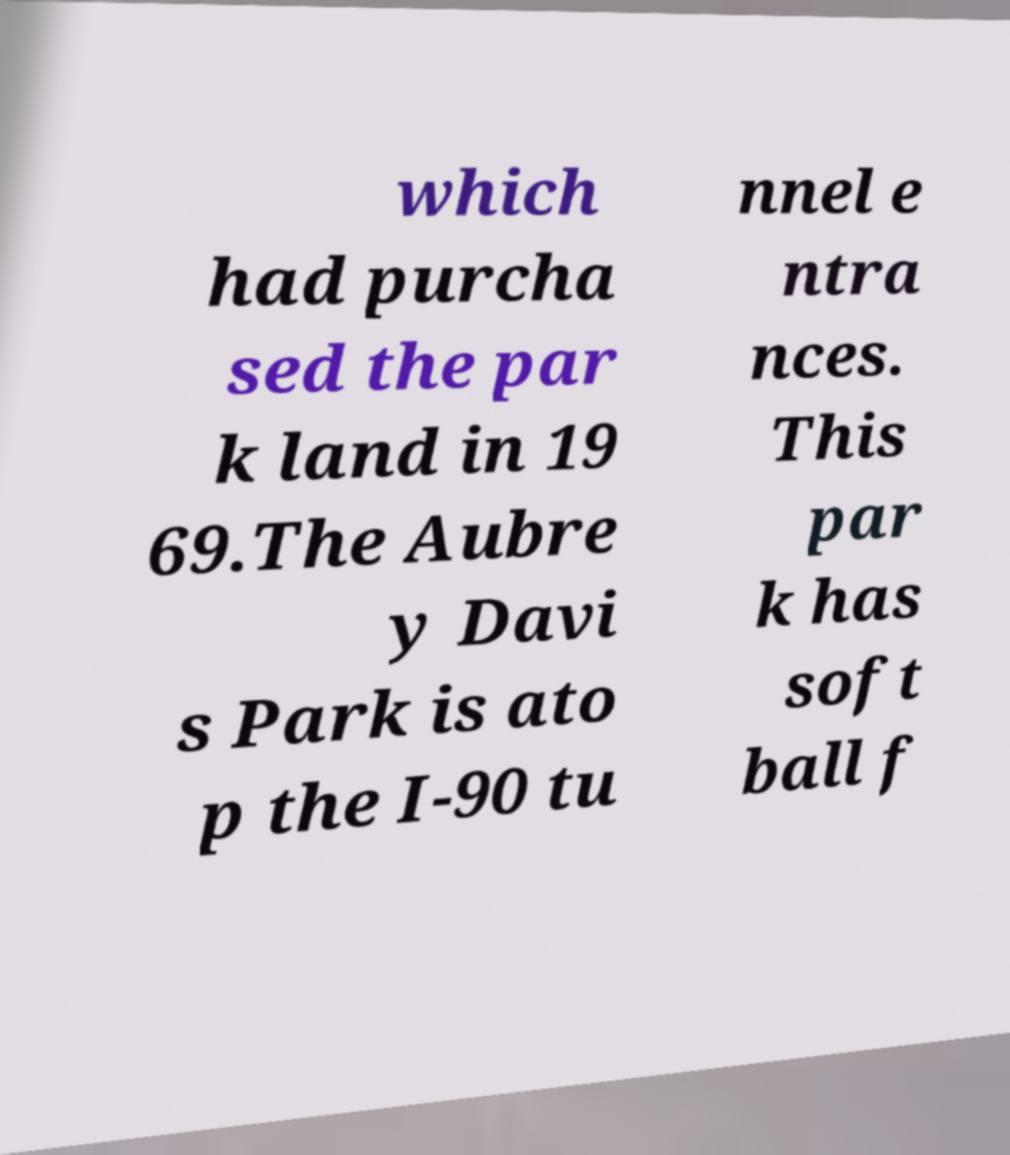What messages or text are displayed in this image? I need them in a readable, typed format. which had purcha sed the par k land in 19 69.The Aubre y Davi s Park is ato p the I-90 tu nnel e ntra nces. This par k has soft ball f 